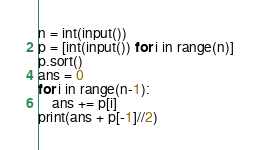<code> <loc_0><loc_0><loc_500><loc_500><_Python_>n = int(input())
p = [int(input()) for i in range(n)]
p.sort()
ans = 0
for i in range(n-1):
    ans += p[i]
print(ans + p[-1]//2)</code> 